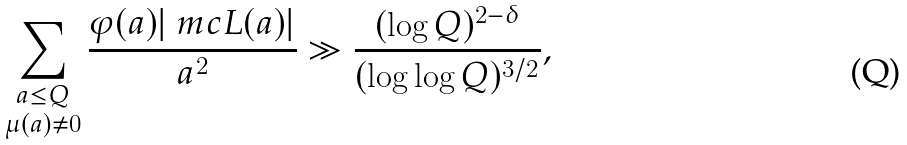Convert formula to latex. <formula><loc_0><loc_0><loc_500><loc_500>\sum _ { \substack { a \leq Q \\ \mu ( a ) \ne 0 } } \frac { \varphi ( a ) | \ m c { L } ( a ) | } { a ^ { 2 } } \gg \frac { ( \log Q ) ^ { 2 - \delta } } { ( \log \log Q ) ^ { 3 / 2 } } ,</formula> 